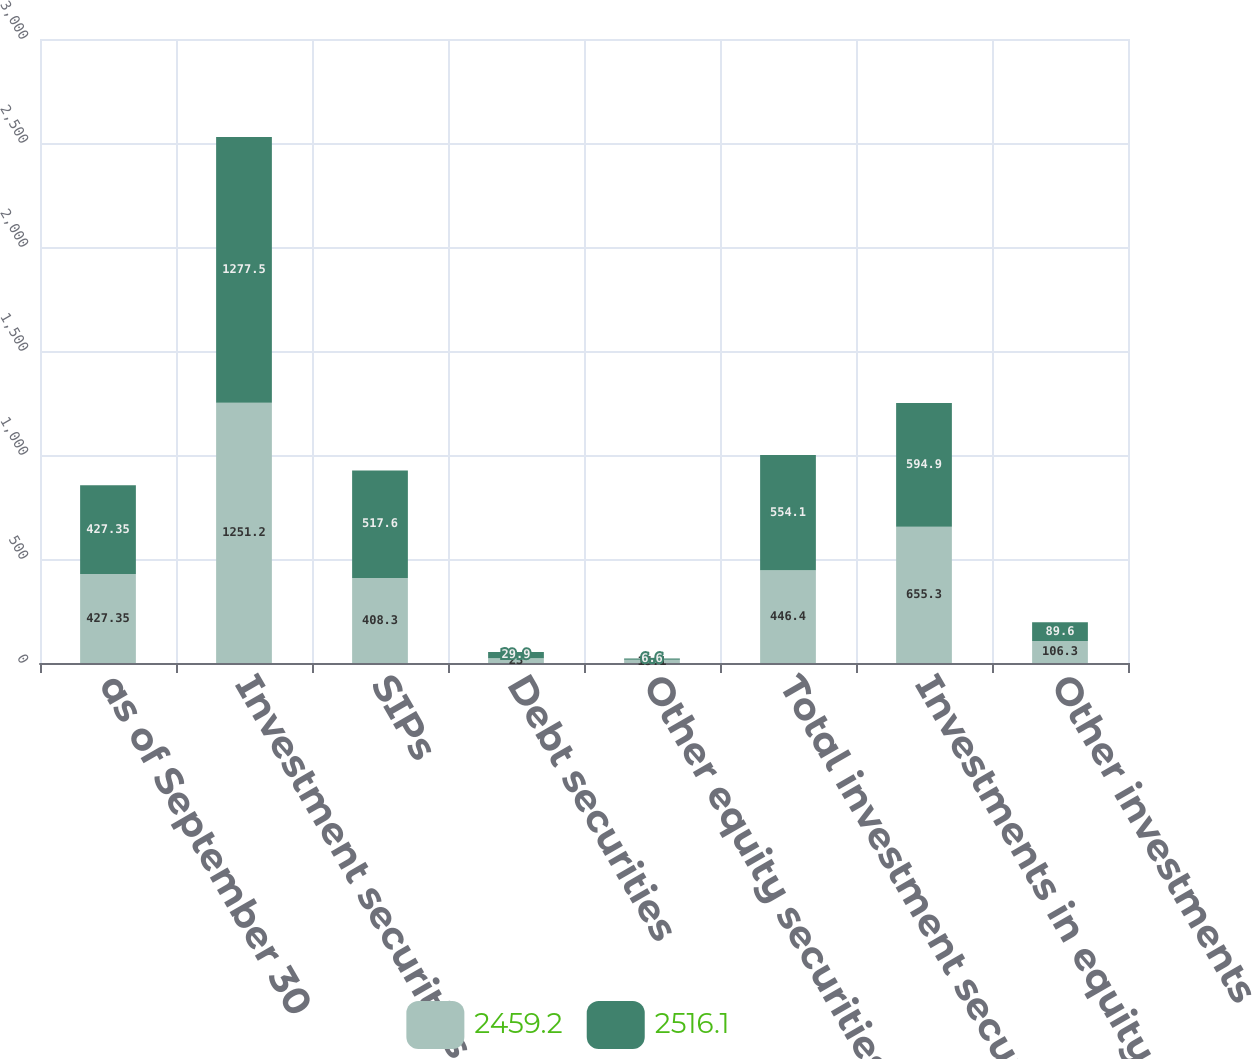Convert chart to OTSL. <chart><loc_0><loc_0><loc_500><loc_500><stacked_bar_chart><ecel><fcel>as of September 30<fcel>Investment securities trading<fcel>SIPs<fcel>Debt securities<fcel>Other equity securities<fcel>Total investment securities<fcel>Investments in equity method<fcel>Other investments<nl><fcel>2459.2<fcel>427.35<fcel>1251.2<fcel>408.3<fcel>23<fcel>15.1<fcel>446.4<fcel>655.3<fcel>106.3<nl><fcel>2516.1<fcel>427.35<fcel>1277.5<fcel>517.6<fcel>29.9<fcel>6.6<fcel>554.1<fcel>594.9<fcel>89.6<nl></chart> 